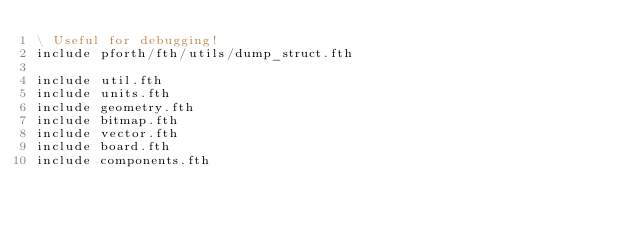Convert code to text. <code><loc_0><loc_0><loc_500><loc_500><_Forth_>\ Useful for debugging!
include pforth/fth/utils/dump_struct.fth

include util.fth
include units.fth
include geometry.fth
include bitmap.fth
include vector.fth
include board.fth
include components.fth
</code> 